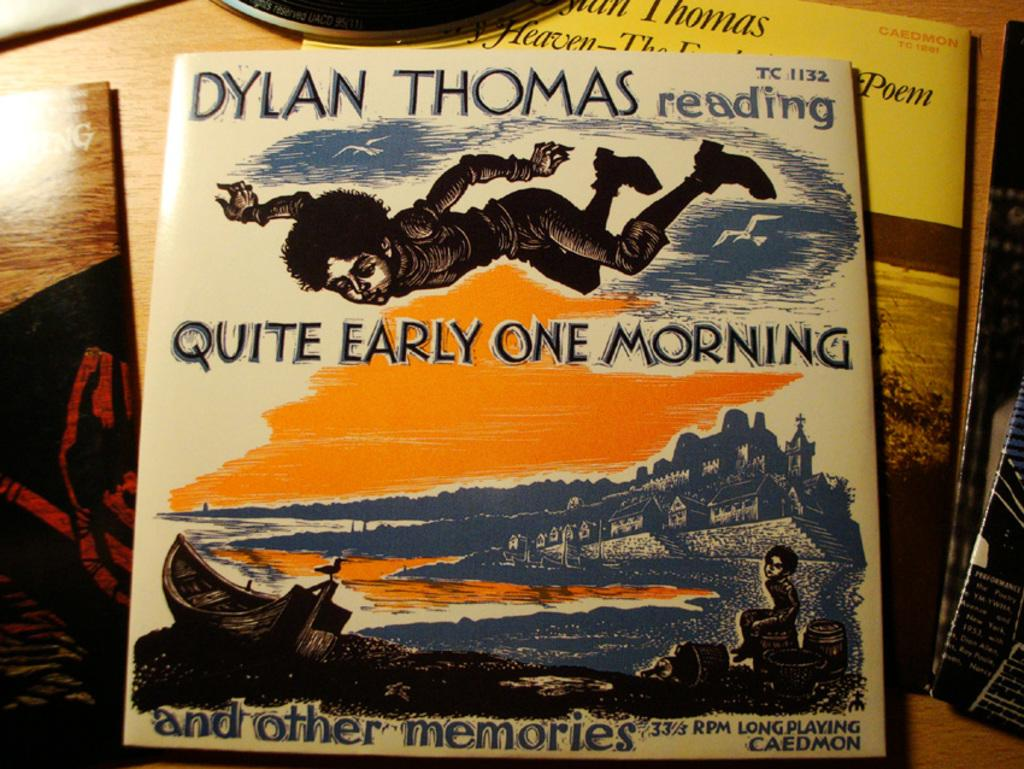<image>
Offer a succinct explanation of the picture presented. the cover for the book quite early one morning written by dylan thomas. 